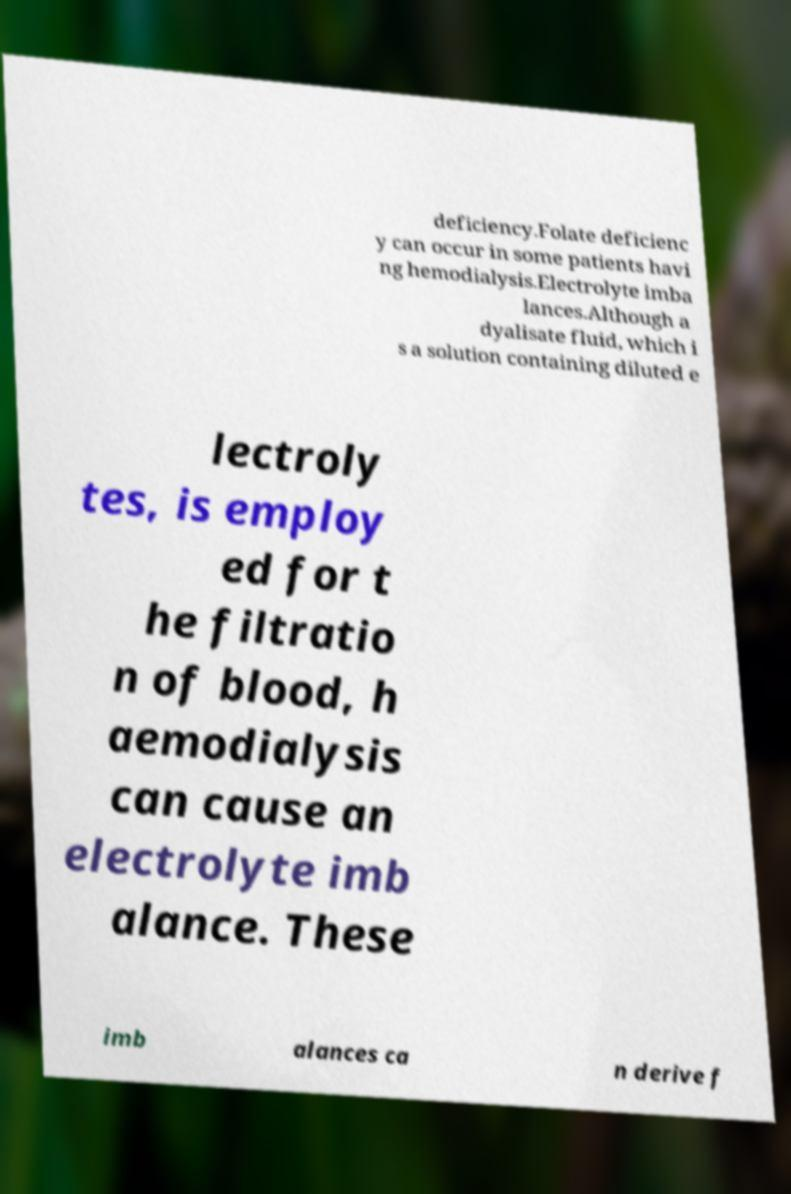Could you extract and type out the text from this image? deficiency.Folate deficienc y can occur in some patients havi ng hemodialysis.Electrolyte imba lances.Although a dyalisate fluid, which i s a solution containing diluted e lectroly tes, is employ ed for t he filtratio n of blood, h aemodialysis can cause an electrolyte imb alance. These imb alances ca n derive f 